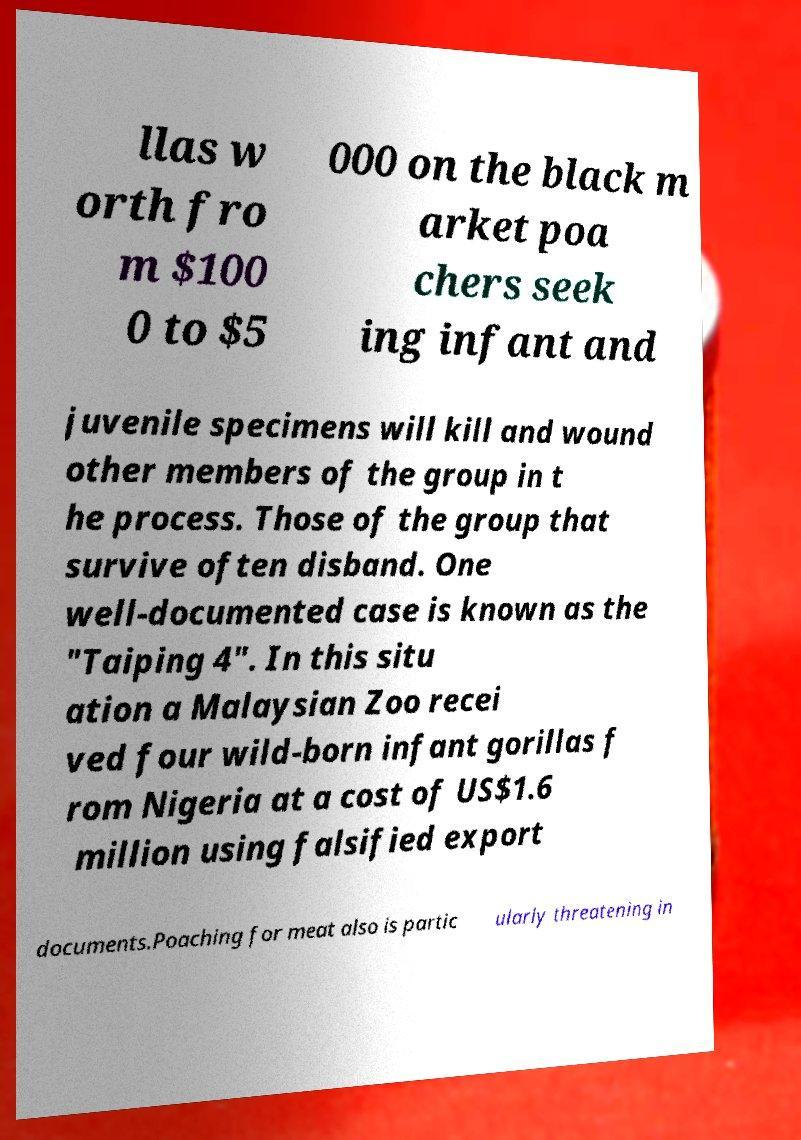Can you read and provide the text displayed in the image?This photo seems to have some interesting text. Can you extract and type it out for me? llas w orth fro m $100 0 to $5 000 on the black m arket poa chers seek ing infant and juvenile specimens will kill and wound other members of the group in t he process. Those of the group that survive often disband. One well-documented case is known as the "Taiping 4". In this situ ation a Malaysian Zoo recei ved four wild-born infant gorillas f rom Nigeria at a cost of US$1.6 million using falsified export documents.Poaching for meat also is partic ularly threatening in 